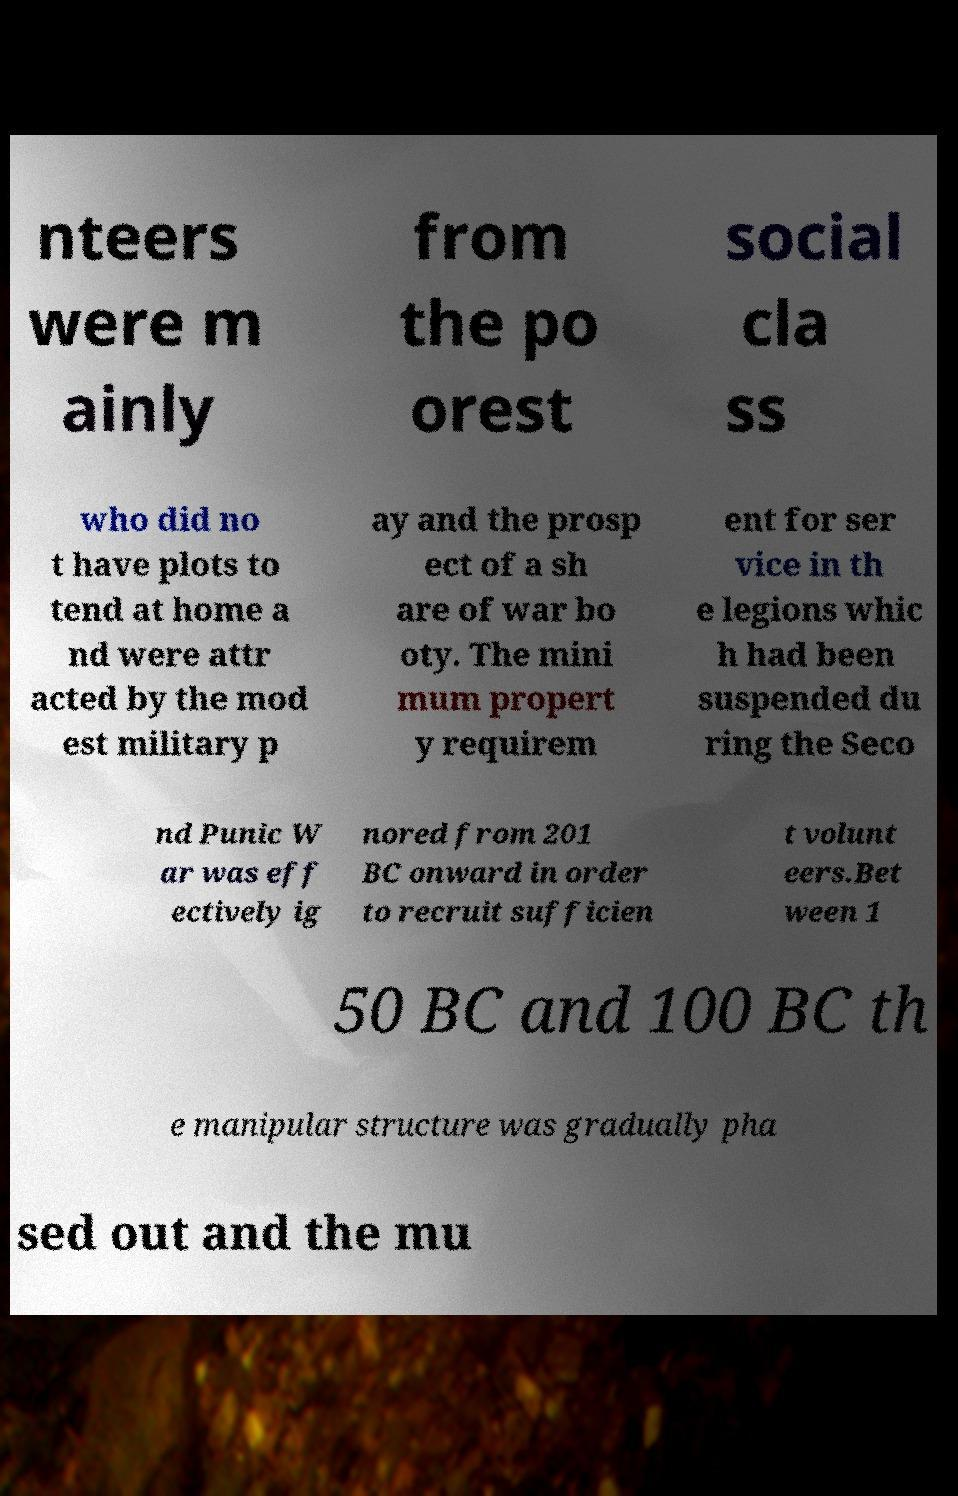I need the written content from this picture converted into text. Can you do that? nteers were m ainly from the po orest social cla ss who did no t have plots to tend at home a nd were attr acted by the mod est military p ay and the prosp ect of a sh are of war bo oty. The mini mum propert y requirem ent for ser vice in th e legions whic h had been suspended du ring the Seco nd Punic W ar was eff ectively ig nored from 201 BC onward in order to recruit sufficien t volunt eers.Bet ween 1 50 BC and 100 BC th e manipular structure was gradually pha sed out and the mu 